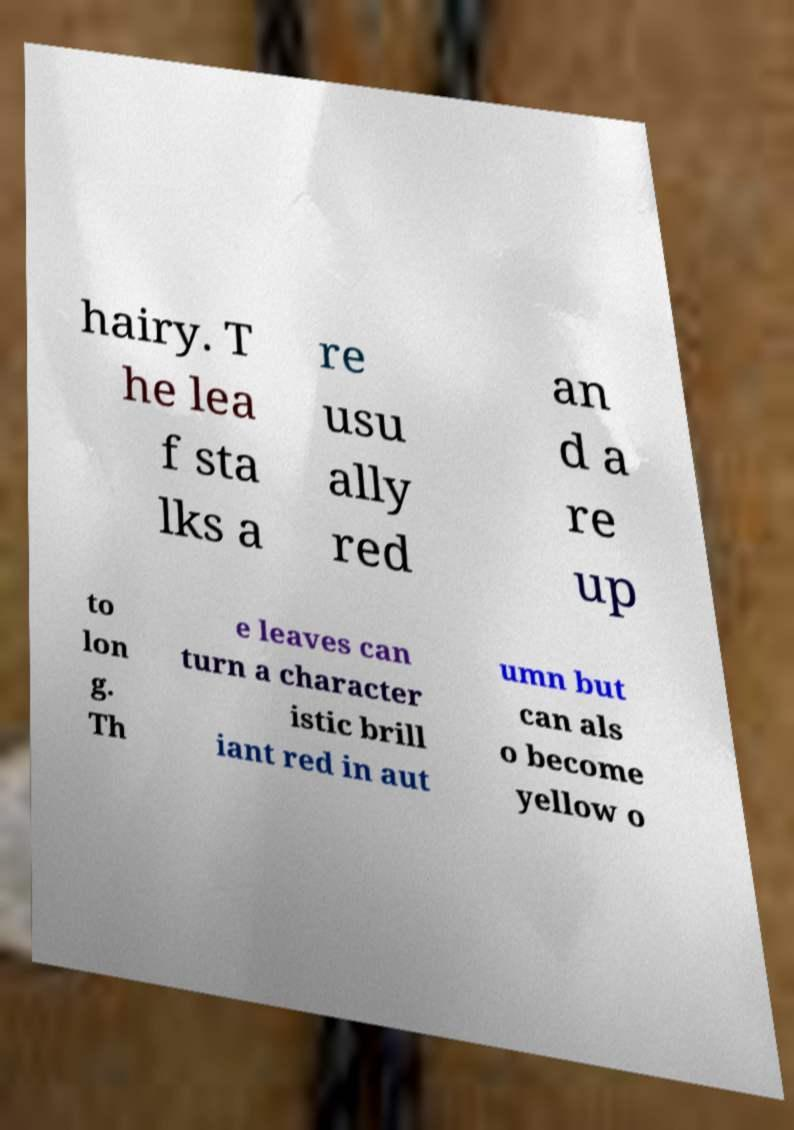There's text embedded in this image that I need extracted. Can you transcribe it verbatim? hairy. T he lea f sta lks a re usu ally red an d a re up to lon g. Th e leaves can turn a character istic brill iant red in aut umn but can als o become yellow o 